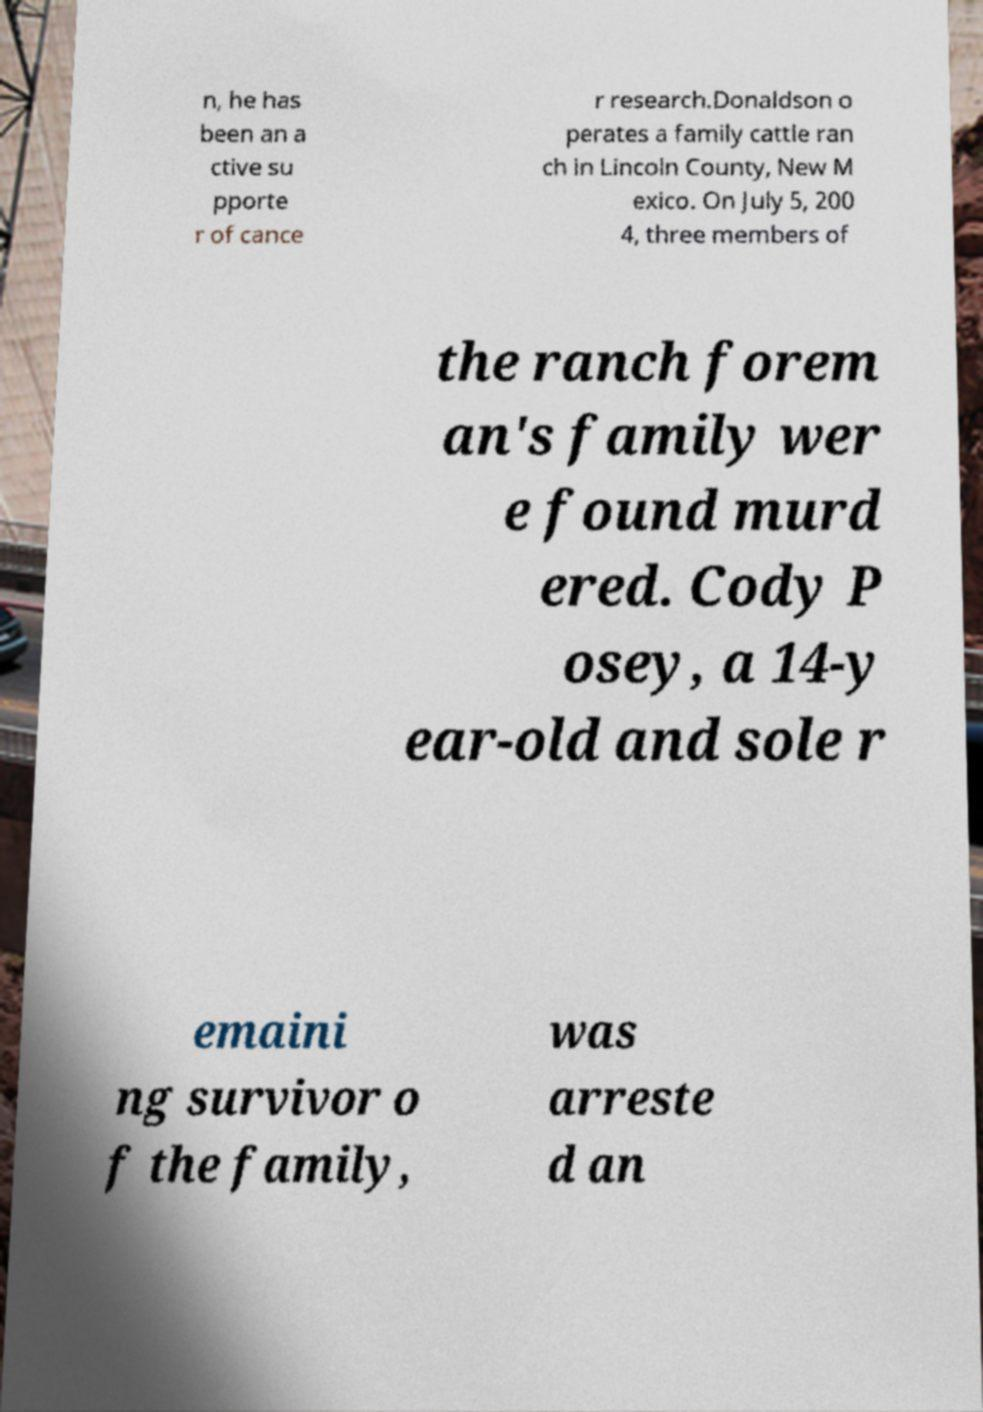Please identify and transcribe the text found in this image. n, he has been an a ctive su pporte r of cance r research.Donaldson o perates a family cattle ran ch in Lincoln County, New M exico. On July 5, 200 4, three members of the ranch forem an's family wer e found murd ered. Cody P osey, a 14-y ear-old and sole r emaini ng survivor o f the family, was arreste d an 